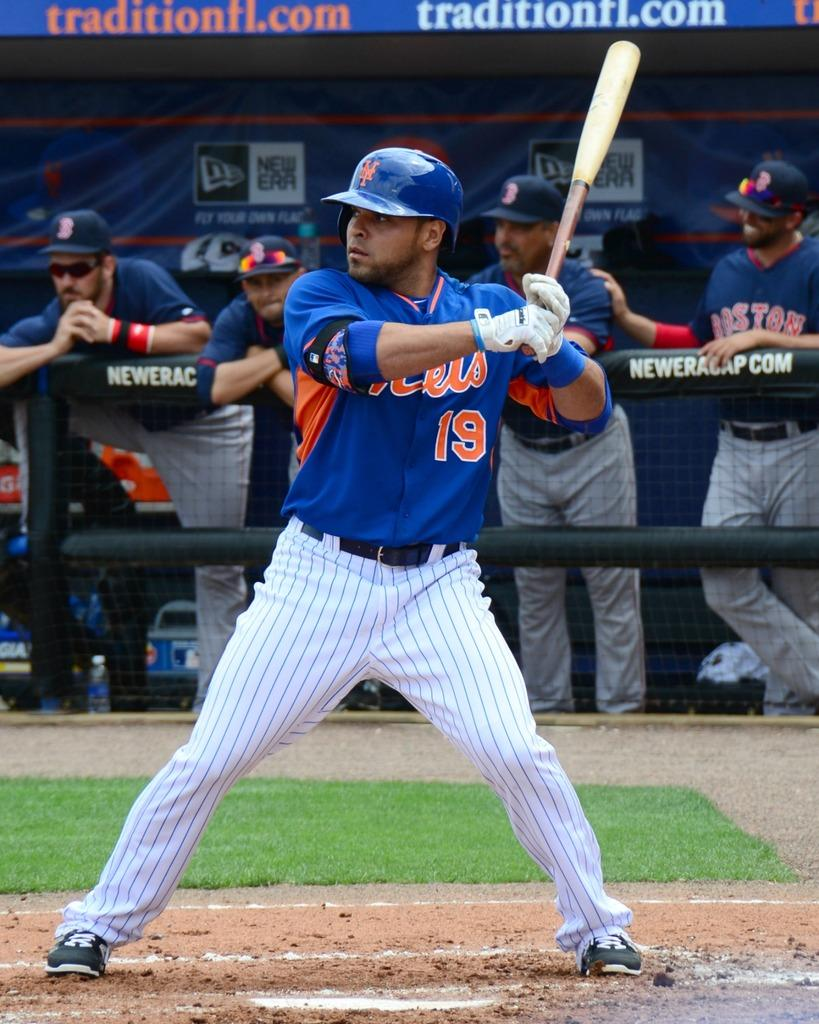Provide a one-sentence caption for the provided image. Batter number 19 is ready for the ball to be pitched. 